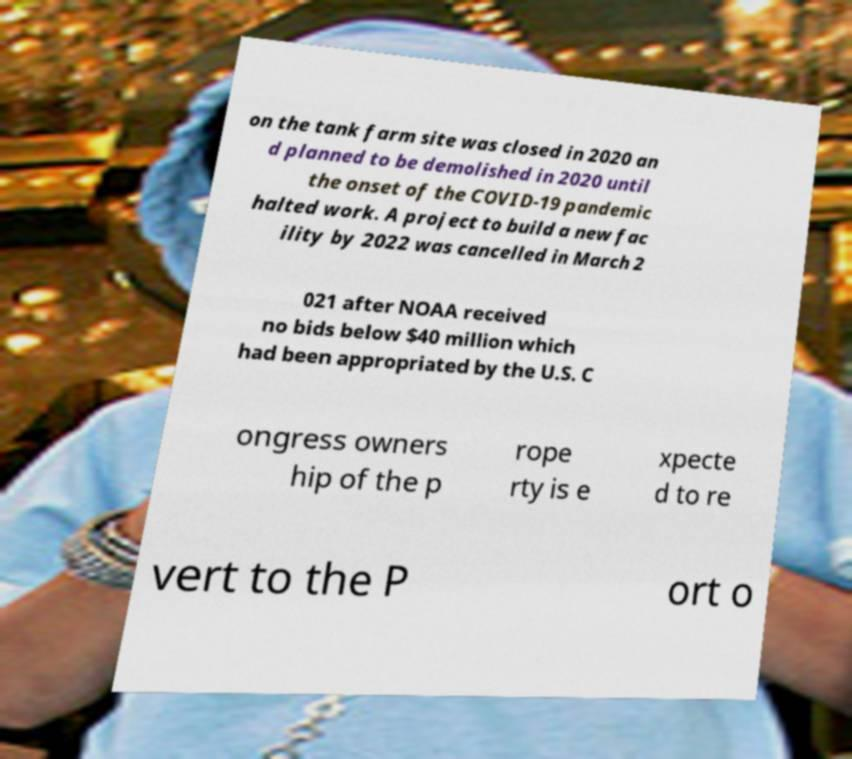Can you accurately transcribe the text from the provided image for me? on the tank farm site was closed in 2020 an d planned to be demolished in 2020 until the onset of the COVID-19 pandemic halted work. A project to build a new fac ility by 2022 was cancelled in March 2 021 after NOAA received no bids below $40 million which had been appropriated by the U.S. C ongress owners hip of the p rope rty is e xpecte d to re vert to the P ort o 